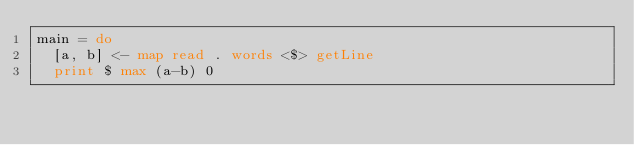Convert code to text. <code><loc_0><loc_0><loc_500><loc_500><_Haskell_>main = do
  [a, b] <- map read . words <$> getLine
  print $ max (a-b) 0</code> 